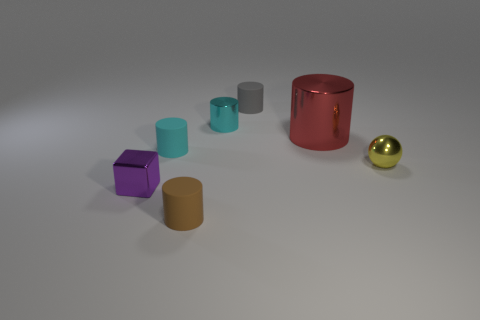The tiny cyan thing that is to the right of the tiny matte object that is in front of the purple shiny thing is made of what material?
Provide a short and direct response. Metal. Is there a small metal object that has the same color as the tiny cube?
Keep it short and to the point. No. What size is the cyan object that is made of the same material as the small gray cylinder?
Provide a short and direct response. Small. Is there any other thing of the same color as the big cylinder?
Your answer should be very brief. No. What color is the shiny cylinder that is to the right of the gray rubber thing?
Make the answer very short. Red. There is a small shiny thing that is on the left side of the small cyan cylinder in front of the big object; are there any gray matte things that are left of it?
Provide a succinct answer. No. Are there more matte objects behind the purple shiny object than yellow objects?
Your answer should be compact. Yes. There is a tiny cyan object behind the large red metal object; is it the same shape as the gray rubber thing?
Ensure brevity in your answer.  Yes. Is there anything else that is made of the same material as the red thing?
Offer a very short reply. Yes. How many objects are either small gray matte cylinders or cylinders right of the small cyan rubber cylinder?
Your answer should be compact. 4. 